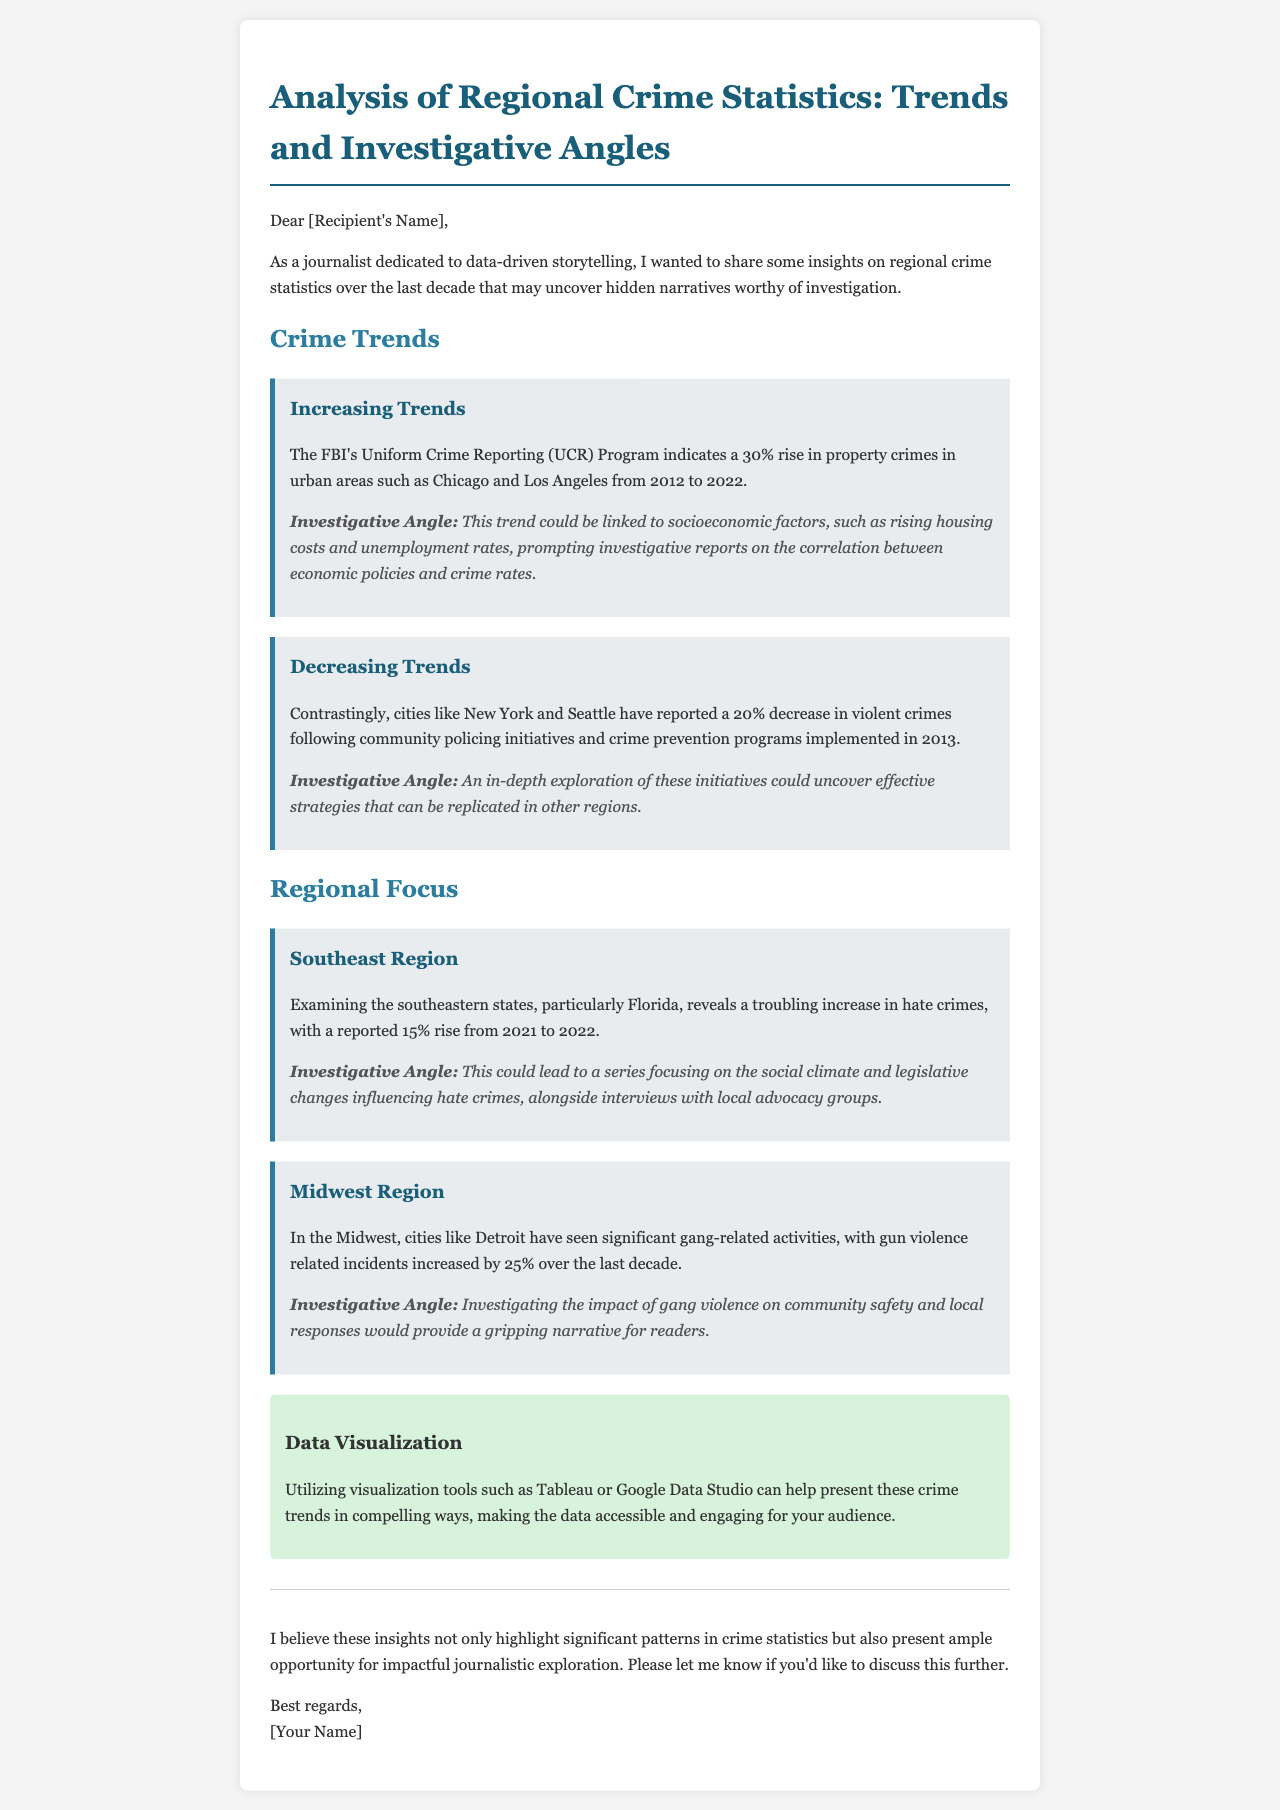What percentage rise in property crimes is reported from 2012 to 2022? The document states that property crimes in urban areas increased by 30% from 2012 to 2022.
Answer: 30% Which two cities reported a 20% decrease in violent crimes? The email mentions New York and Seattle as cities where violent crimes decreased by 20%.
Answer: New York and Seattle What regional increase in hate crimes is highlighted in the document? The email specifies a 15% rise in hate crimes in Florida from 2021 to 2022.
Answer: 15% What impact of community policing initiatives is mentioned? The document indicates that community policing initiatives led to a 20% decrease in violent crimes in specific cities.
Answer: 20% decrease What type of visualization tools are suggested for presenting crime trends? The email recommends using Tableau or Google Data Studio for data visualization.
Answer: Tableau or Google Data Studio What could investigative reporting on rising property crimes explore? The email suggests examining socioeconomic factors like housing costs and unemployment rates related to rising property crimes.
Answer: Socioeconomic factors What crime-related topic is notably examined in the Midwest? The document highlights significant gang-related activities and an increase in gun violence in the Midwest.
Answer: Gang-related activities What is the primary focus of the consultation offered at the end of the email? The message suggests discussing the insights and opportunities for journalistic exploration further.
Answer: Discuss insights and opportunities 